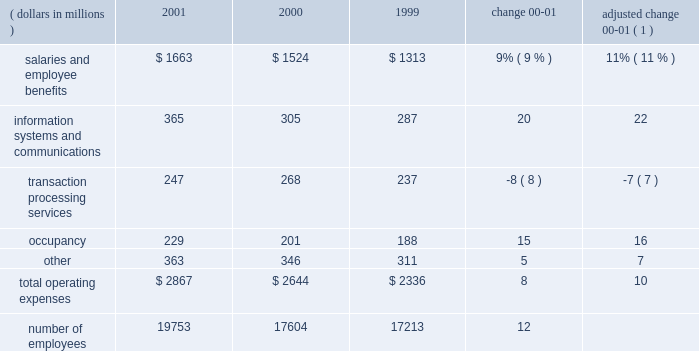Operating expenses operating expenses were $ 2.9 billion , an increase of 8% ( 8 % ) over 2000 .
Adjusted for the formation of citistreet , operating expenses grew 10% ( 10 % ) .
Expense growth in 2001 of 10% ( 10 % ) is significantly lower than the comparable 20% ( 20 % ) expense growth for 2000 compared to 1999 .
State street successfully reduced the growth rate of expenses as revenue growth slowed during the latter half of 2000 and early 2001 .
The expense growth in 2001 reflects higher expenses for salaries and employee benefits , as well as information systems and communications .
O p e r a t i n g e x p e n s e s ( dollars in millions ) 2001 2000 1999 change adjusted change 00-01 ( 1 ) .
( 1 ) 2000 results adjusted for the formation of citistreet expenses related to salaries and employee benefits increased $ 139million in 2001 , or $ 163millionwhen adjusted for the formation of citistreet .
The adjusted increase reflects more than 2100 additional staff to support the large client wins and new business from existing clients and acquisitions .
This expense increase was partially offset by lower incentive-based compensation .
Information systems and communications expense was $ 365 million in 2001 , up 20% ( 20 % ) from the prior year .
Adjusted for the formation of citistreet , information systems and communications expense increased 22% ( 22 % ) .
This growth reflects both continuing investment in software and hardware , aswell as the technology costs associated with increased staffing levels .
Expenses related to transaction processing services were $ 247 million , down $ 21 million , or 8% ( 8 % ) .
These expenses are volume related and include external contract services , subcustodian fees , brokerage services and fees related to securities settlement .
Lower mutual fund shareholder activities , and lower subcustodian fees resulting from both the decline in asset values and lower transaction volumes , drove the decline .
Occupancy expensewas $ 229million , up 15% ( 15 % ) .
The increase is due to expenses necessary to support state street 2019s global growth , and expenses incurred for leasehold improvements and other operational costs .
Other expenses were $ 363 million , up $ 17 million , or 5% ( 5 % ) .
These expenses include professional services , advertising and sales promotion , and internal operational expenses .
The increase over prior year is due to a $ 21 million increase in the amortization of goodwill , primarily from acquisitions in 2001 .
In accordance with recent accounting pronouncements , goodwill amortization expense will be eliminated in 2002 .
State street recorded approximately $ 38 million , or $ .08 per share after tax , of goodwill amortization expense in 2001 .
State street 2019s cost containment efforts , which reduced discretionary spending , partially offset the increase in other expenses .
State street corporation 9 .
What was the percent change in salaries and employee benefits between 1999 and 2000? 
Computations: ((1524 - 1313) / 1313)
Answer: 0.1607. 